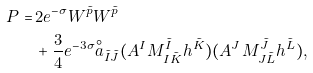Convert formula to latex. <formula><loc_0><loc_0><loc_500><loc_500>P = & \, 2 e ^ { - \sigma } W ^ { \tilde { p } } W ^ { \tilde { p } } \\ & \, + \frac { 3 } { 4 } e ^ { - 3 \sigma } { \stackrel { \circ } { a } } _ { \tilde { I } \tilde { J } } ( A ^ { I } M _ { I \tilde { K } } ^ { \tilde { I } } h ^ { \tilde { K } } ) ( A ^ { J } M _ { J \tilde { L } } ^ { \tilde { J } } h ^ { \tilde { L } } ) ,</formula> 